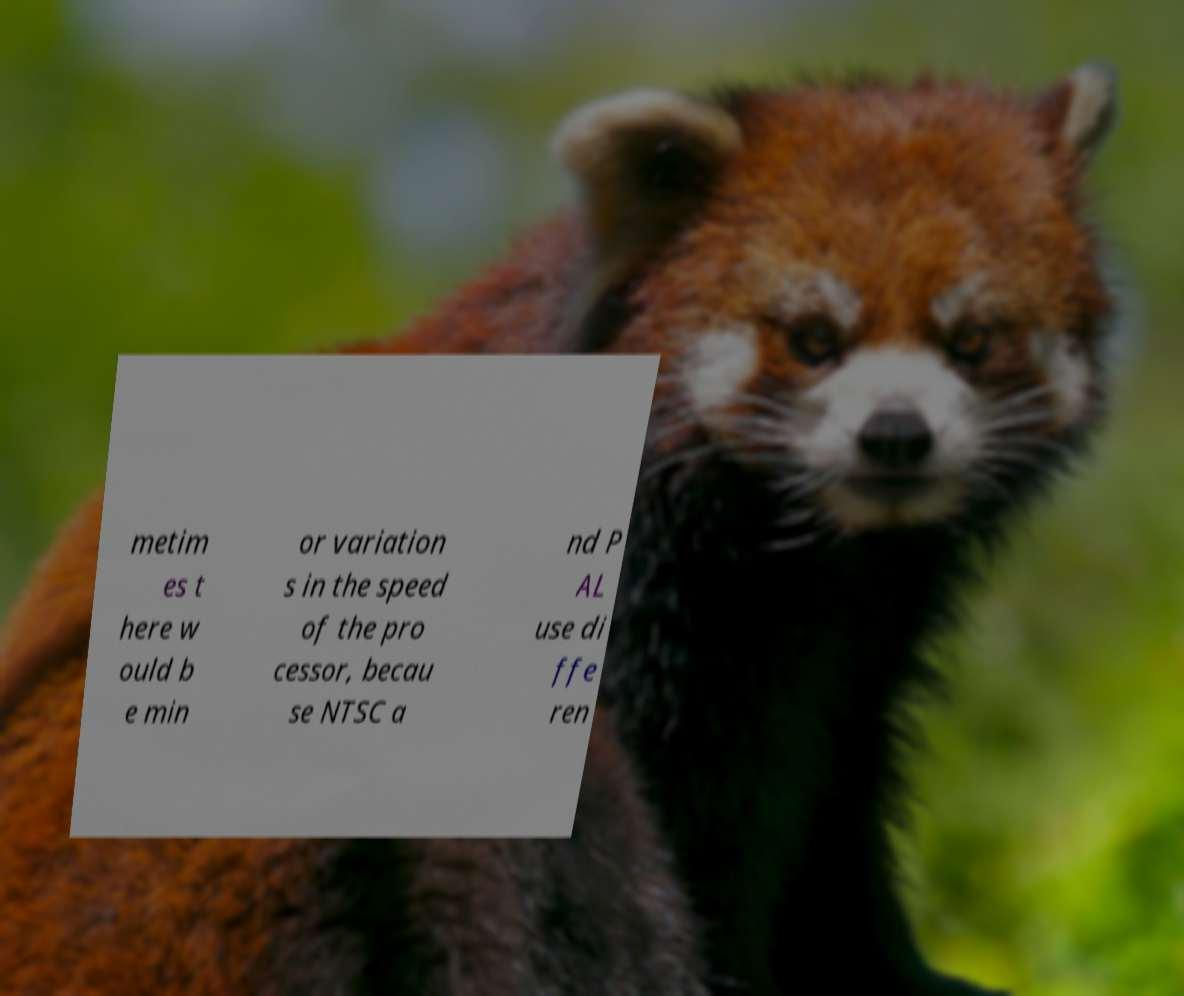Can you accurately transcribe the text from the provided image for me? metim es t here w ould b e min or variation s in the speed of the pro cessor, becau se NTSC a nd P AL use di ffe ren 